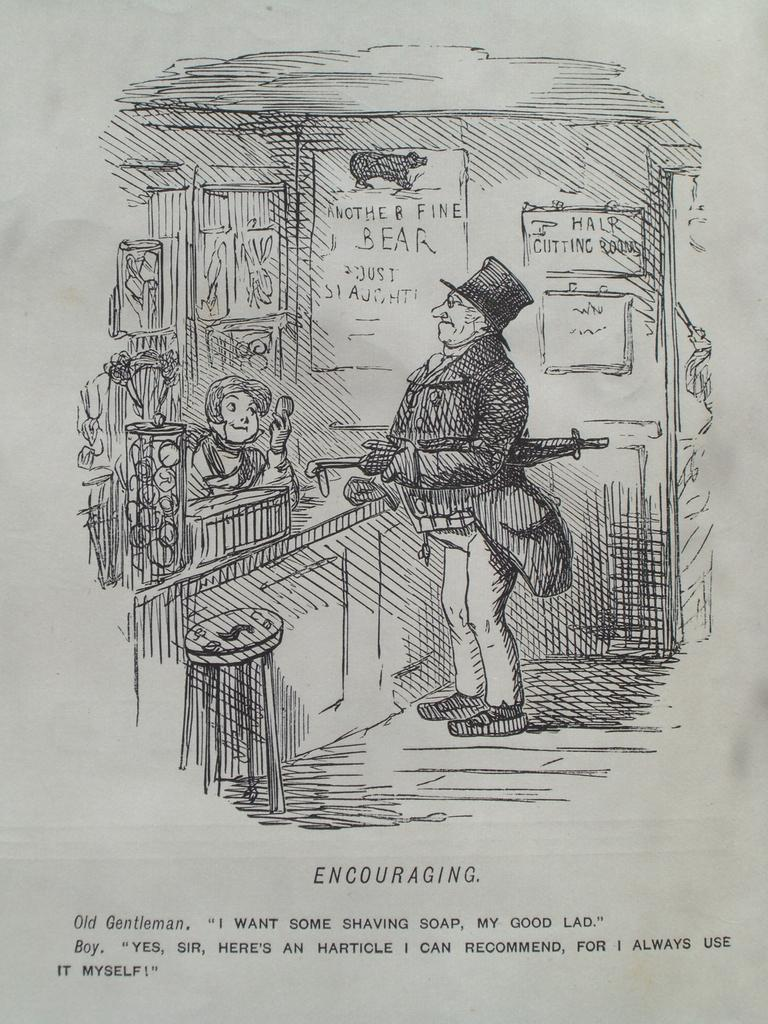What is depicted on the paper in the image? There is a sketch of a man and a woman on a paper. Is there any text accompanying the sketch? Yes, there is text at the bottom of the paper. How many kittens are sitting on the man's lap in the image? There are no kittens present in the image; it features a sketch of a man and a woman on a paper with accompanying text. 